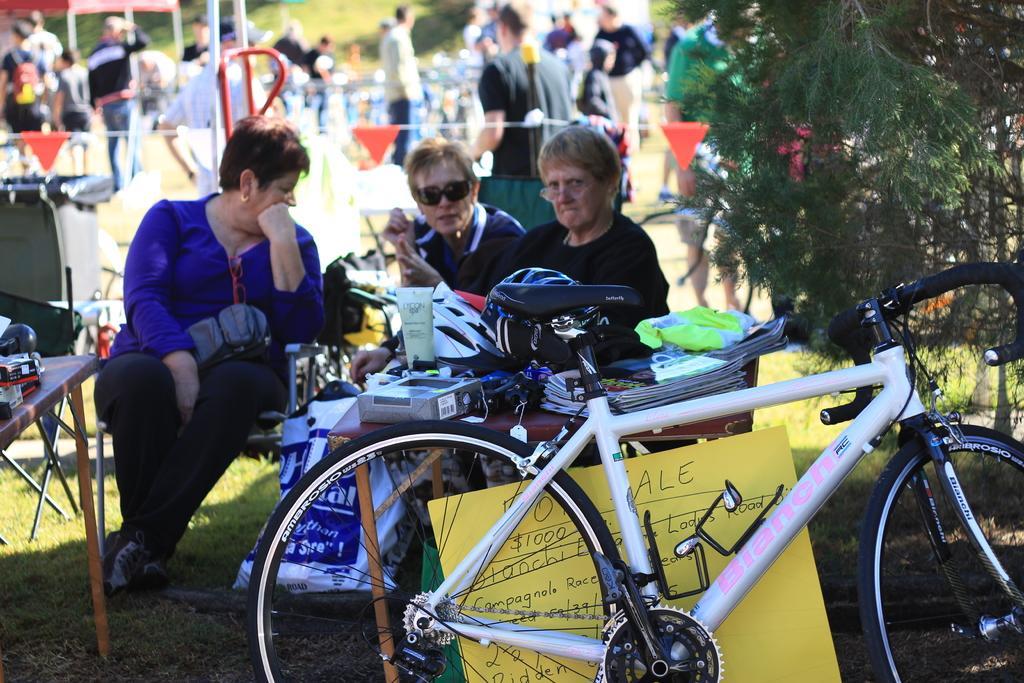Describe this image in one or two sentences. In this picture we can see three persons sitting and in front of them there is a table full of books, box and in front of it is a bicycle and a chart over there and the background we can see crowd of people, grass, tree, flags and beside the person there is one more table. 